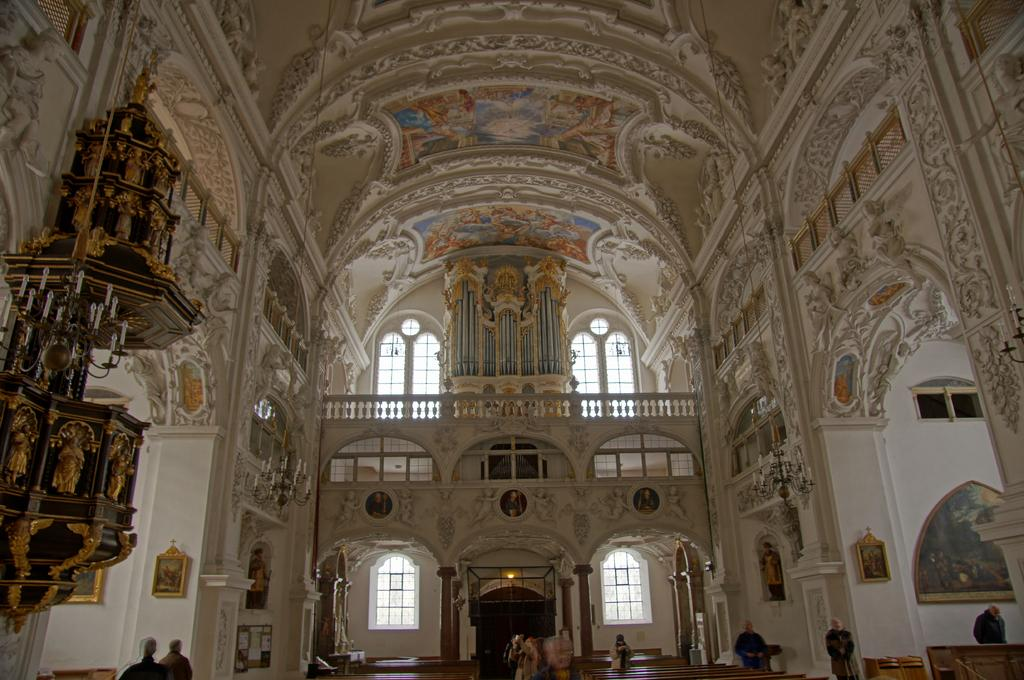What type of building is depicted in the image? The image is an inner view of a church. What can be seen on the floor in the image? There are wooden benches in the image. What is present on the walls in the image? There are photo frames on the wall in the image. Are there any people in the image? Yes, people are present in the image. What objects are used for lighting in the image? There are candle stands in the image. Can you see the road outside the church in the image? There is no road visible in the image, as it is an inner view of the church. 